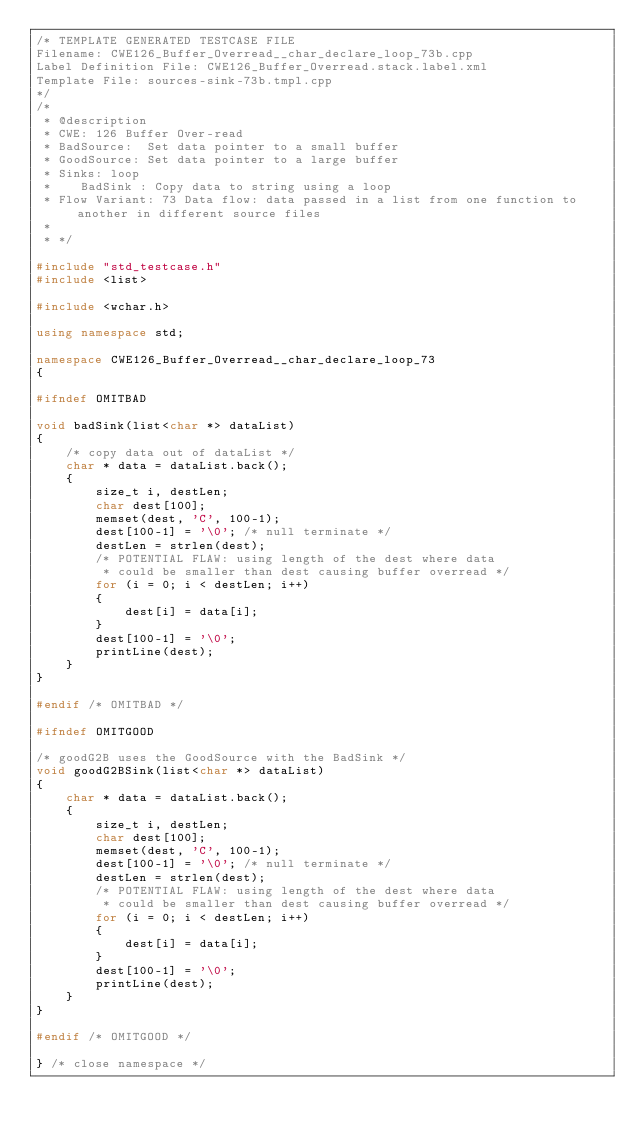Convert code to text. <code><loc_0><loc_0><loc_500><loc_500><_C++_>/* TEMPLATE GENERATED TESTCASE FILE
Filename: CWE126_Buffer_Overread__char_declare_loop_73b.cpp
Label Definition File: CWE126_Buffer_Overread.stack.label.xml
Template File: sources-sink-73b.tmpl.cpp
*/
/*
 * @description
 * CWE: 126 Buffer Over-read
 * BadSource:  Set data pointer to a small buffer
 * GoodSource: Set data pointer to a large buffer
 * Sinks: loop
 *    BadSink : Copy data to string using a loop
 * Flow Variant: 73 Data flow: data passed in a list from one function to another in different source files
 *
 * */

#include "std_testcase.h"
#include <list>

#include <wchar.h>

using namespace std;

namespace CWE126_Buffer_Overread__char_declare_loop_73
{

#ifndef OMITBAD

void badSink(list<char *> dataList)
{
    /* copy data out of dataList */
    char * data = dataList.back();
    {
        size_t i, destLen;
        char dest[100];
        memset(dest, 'C', 100-1);
        dest[100-1] = '\0'; /* null terminate */
        destLen = strlen(dest);
        /* POTENTIAL FLAW: using length of the dest where data
         * could be smaller than dest causing buffer overread */
        for (i = 0; i < destLen; i++)
        {
            dest[i] = data[i];
        }
        dest[100-1] = '\0';
        printLine(dest);
    }
}

#endif /* OMITBAD */

#ifndef OMITGOOD

/* goodG2B uses the GoodSource with the BadSink */
void goodG2BSink(list<char *> dataList)
{
    char * data = dataList.back();
    {
        size_t i, destLen;
        char dest[100];
        memset(dest, 'C', 100-1);
        dest[100-1] = '\0'; /* null terminate */
        destLen = strlen(dest);
        /* POTENTIAL FLAW: using length of the dest where data
         * could be smaller than dest causing buffer overread */
        for (i = 0; i < destLen; i++)
        {
            dest[i] = data[i];
        }
        dest[100-1] = '\0';
        printLine(dest);
    }
}

#endif /* OMITGOOD */

} /* close namespace */
</code> 